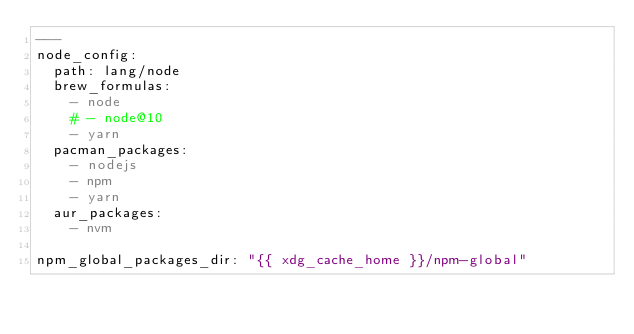Convert code to text. <code><loc_0><loc_0><loc_500><loc_500><_YAML_>---
node_config:
  path: lang/node
  brew_formulas:
    - node
    # - node@10
    - yarn
  pacman_packages:
    - nodejs
    - npm
    - yarn
  aur_packages:
    - nvm

npm_global_packages_dir: "{{ xdg_cache_home }}/npm-global"
</code> 